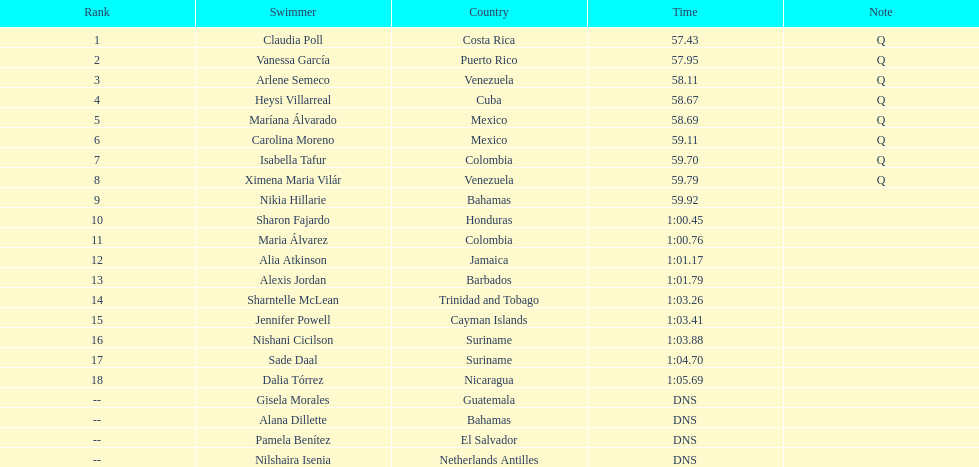Give me the full table as a dictionary. {'header': ['Rank', 'Swimmer', 'Country', 'Time', 'Note'], 'rows': [['1', 'Claudia Poll', 'Costa Rica', '57.43', 'Q'], ['2', 'Vanessa García', 'Puerto Rico', '57.95', 'Q'], ['3', 'Arlene Semeco', 'Venezuela', '58.11', 'Q'], ['4', 'Heysi Villarreal', 'Cuba', '58.67', 'Q'], ['5', 'Maríana Álvarado', 'Mexico', '58.69', 'Q'], ['6', 'Carolina Moreno', 'Mexico', '59.11', 'Q'], ['7', 'Isabella Tafur', 'Colombia', '59.70', 'Q'], ['8', 'Ximena Maria Vilár', 'Venezuela', '59.79', 'Q'], ['9', 'Nikia Hillarie', 'Bahamas', '59.92', ''], ['10', 'Sharon Fajardo', 'Honduras', '1:00.45', ''], ['11', 'Maria Álvarez', 'Colombia', '1:00.76', ''], ['12', 'Alia Atkinson', 'Jamaica', '1:01.17', ''], ['13', 'Alexis Jordan', 'Barbados', '1:01.79', ''], ['14', 'Sharntelle McLean', 'Trinidad and Tobago', '1:03.26', ''], ['15', 'Jennifer Powell', 'Cayman Islands', '1:03.41', ''], ['16', 'Nishani Cicilson', 'Suriname', '1:03.88', ''], ['17', 'Sade Daal', 'Suriname', '1:04.70', ''], ['18', 'Dalia Tórrez', 'Nicaragua', '1:05.69', ''], ['--', 'Gisela Morales', 'Guatemala', 'DNS', ''], ['--', 'Alana Dillette', 'Bahamas', 'DNS', ''], ['--', 'Pamela Benítez', 'El Salvador', 'DNS', ''], ['--', 'Nilshaira Isenia', 'Netherlands Antilles', 'DNS', '']]} How many competitors did not initiate the preliminaries? 4. 